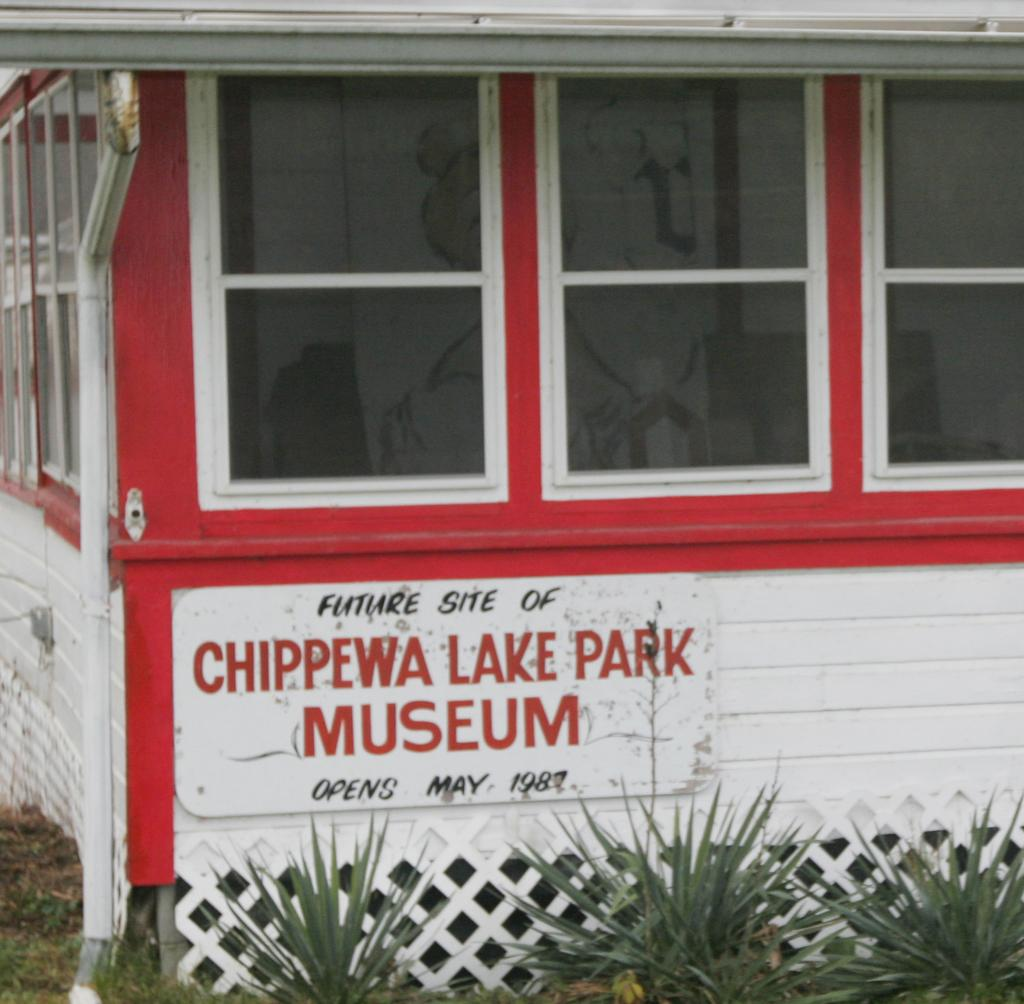What type of structure is present in the image? There is a building in the image. What feature of the building is mentioned in the facts? The building has windows. Are there any other objects or elements in the image besides the building? Yes, there is a pipe and plants visible in the image. Is there any text or writing present in the image? Yes, there is text or writing visible in the image. Can you see a ghost wearing a collar in the image? No, there is no ghost or collar present in the image. What type of basket is used to hold the plants in the image? There is no basket mentioned or visible in the image; the plants are not contained in a basket. 